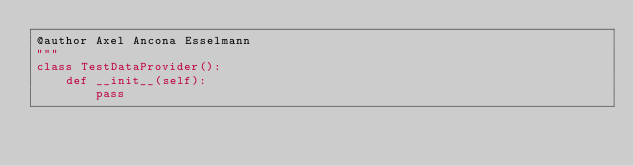<code> <loc_0><loc_0><loc_500><loc_500><_Python_>@author Axel Ancona Esselmann
"""
class TestDataProvider():
    def __init__(self):
        pass
    </code> 